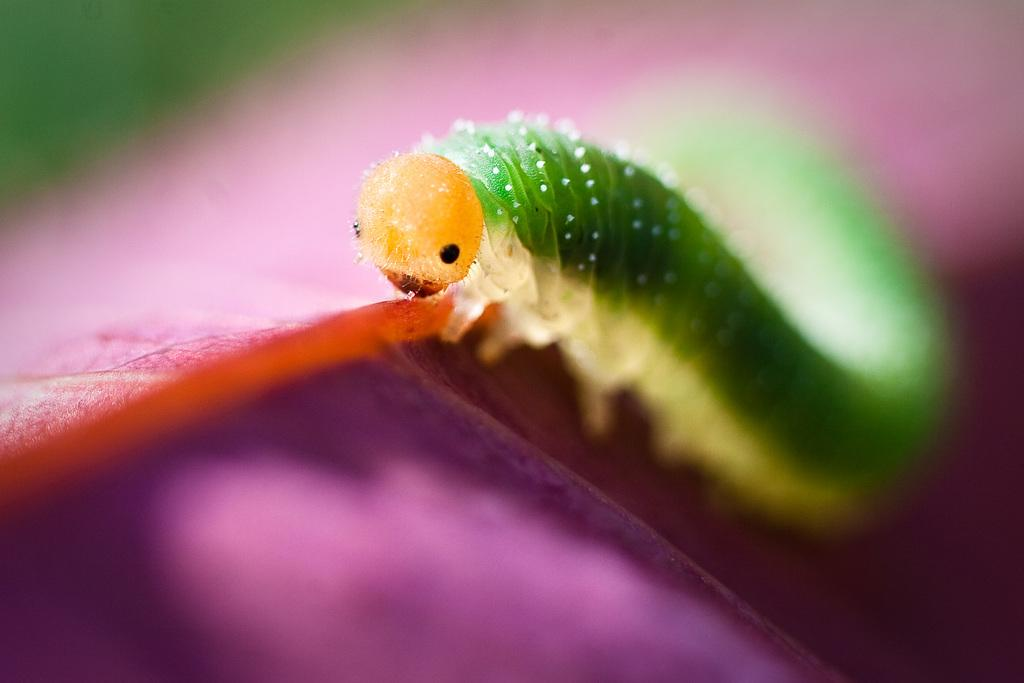What type of creature can be seen in the image? There is an insect in the image. Can you describe the background of the image? The background of the image is blurred. What type of expert advice can be found in the image? There is no expert advice present in the image; it features an insect and a blurred background. What type of waves can be seen in the image? There are no waves present in the image; it features an insect and a blurred background. 